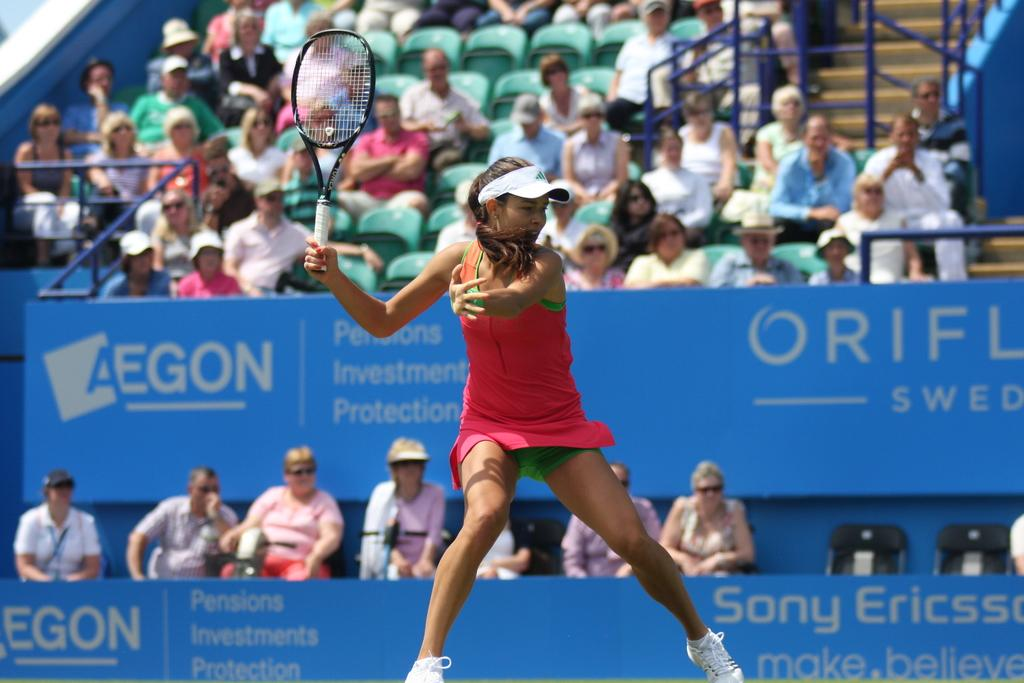What is the woman in the image doing? The woman is playing a tennis game. What object is the woman holding in her hand? The woman is holding a bat in her hand. What type of headwear is the woman wearing? The woman is wearing a cap. Can you describe the people in the background of the image? There are people sitting in the background, watching the game. What type of dirt is visible on the tennis court in the image? There is no dirt visible on the tennis court in the image, as it is likely a hard surface court. 